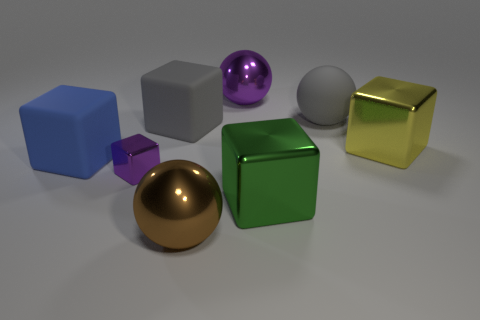Subtract all yellow blocks. How many blocks are left? 4 Subtract all gray matte blocks. How many blocks are left? 4 Subtract 2 blocks. How many blocks are left? 3 Add 1 big blue shiny spheres. How many objects exist? 9 Subtract all cyan cubes. Subtract all green spheres. How many cubes are left? 5 Subtract all balls. How many objects are left? 5 Add 5 large gray cubes. How many large gray cubes are left? 6 Add 2 yellow cubes. How many yellow cubes exist? 3 Subtract 0 cyan blocks. How many objects are left? 8 Subtract all tiny blocks. Subtract all big yellow cubes. How many objects are left? 6 